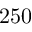Convert formula to latex. <formula><loc_0><loc_0><loc_500><loc_500>2 5 0</formula> 